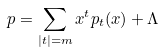Convert formula to latex. <formula><loc_0><loc_0><loc_500><loc_500>p = \sum _ { | t | = m } x ^ { t } p _ { t } ( x ) + \Lambda</formula> 